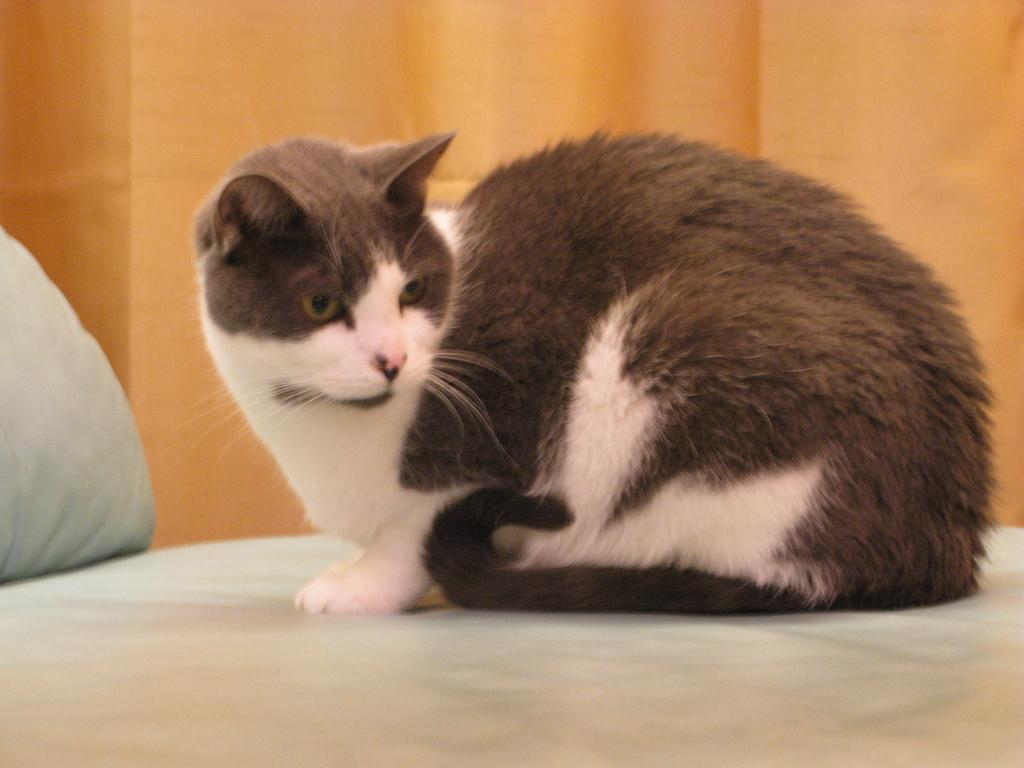What type of furniture is in the image? There is a couch in the image. What color is the couch? The couch is white. What type of animal is in the image? There is a cat in the image. What colors are on the cat? The cat is white and brown. What can be seen in the background of the image? There is an orange object in the background of the image. What type of tooth is visible in the image? There is no tooth present in the image. What emotion does the cat appear to be feeling in the image? The image does not convey any emotions, so it is not possible to determine how the cat feels. 